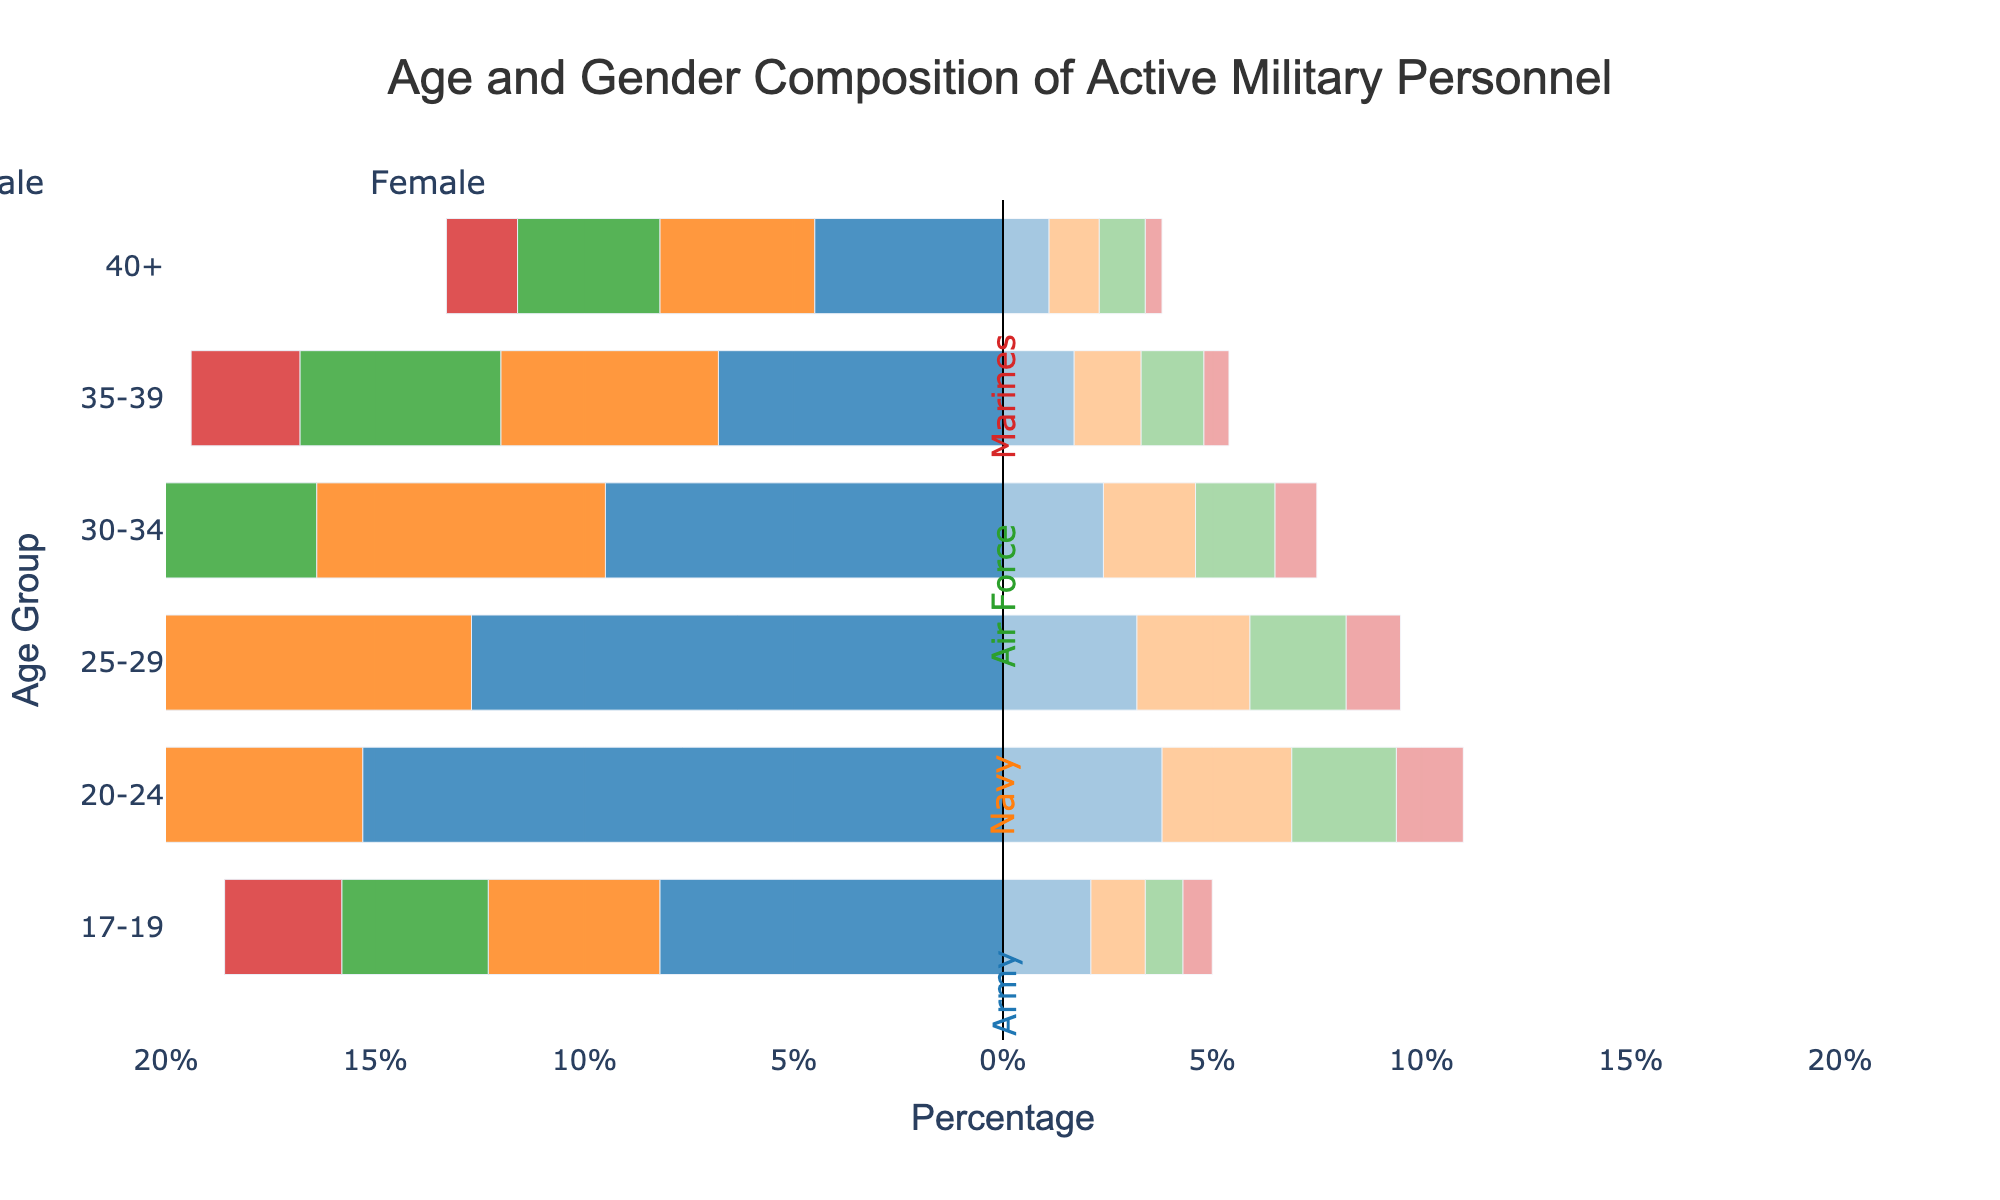Which branch has the highest percentage of male personnel aged 20-24? Look at the bar lengths representing males in the 20-24 age group across all branches. The Army has the longest bar, indicating the highest percentage.
Answer: Army Which age group has the smallest percentage of female personnel in the Marines? Compare the orange bars (female) across all age groups in the Marine branch. The age group 40+ has the shortest bar, representing the smallest percentage.
Answer: 40+ What is the combined percentage of male personnel aged 25-29 in the Navy and Air Force? Look at the bars for males aged 25-29 in both the Navy and Air Force. The percentages are 8.6% and 7.2%, respectively, so the combined percentage is 8.6 + 7.2.
Answer: 15.8% Which branch has the most gender-balanced composition in the age group 30-34? Look at the bars representing males and females in the 30-34 age group across all branches. The Air Force has the smallest difference between male and female percentages.
Answer: Air Force What is the total percentage of personnel aged 17-19 across all branches? Sum the percentages of all personnel aged 17-19 for all branches: 8.2 (Army) + 4.1 (Navy) + 3.5 (Air Force) + 2.8 (Marines) + 2.1 (Army) + 1.3 (Navy) + 0.9 (Air Force) + 0.7 (Marines). The sum is 23.6.
Answer: 23.6% Which branch has the least percentage of personnel aged 35-39? Compare the sums of male and female percentages aged 35-39 for all branches. The Marines have the lowest sum with 2.6 (male) + 0.6 (female).
Answer: Marines Which branch has a higher percentage of female personnel aged 20-24, the Navy or the Air Force? Look at the orange bars for females aged 20-24 in both the Navy and Air Force. The Navy has a higher percentage (3.1%) compared to the Air Force (2.5%).
Answer: Navy How does the percentage of males aged 40+ in the Army compare to that in the Marines? Compare the bars for males aged 40+ in the Army and Marines. The Army has 4.5%, whereas the Marines have 1.7%. The Army has a higher percentage.
Answer: Army 